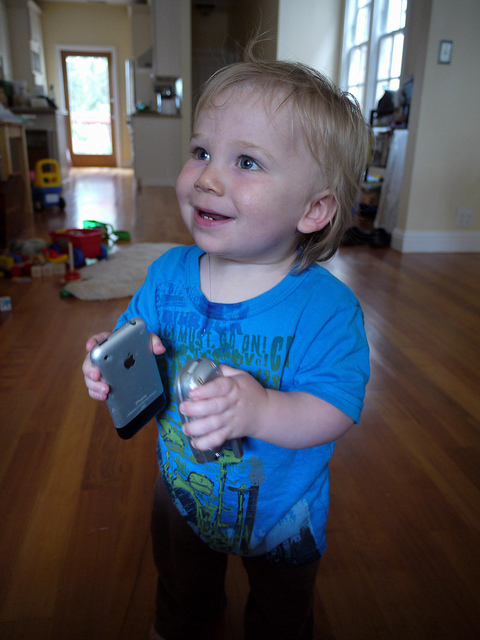Identify the text contained in this image. ON C 